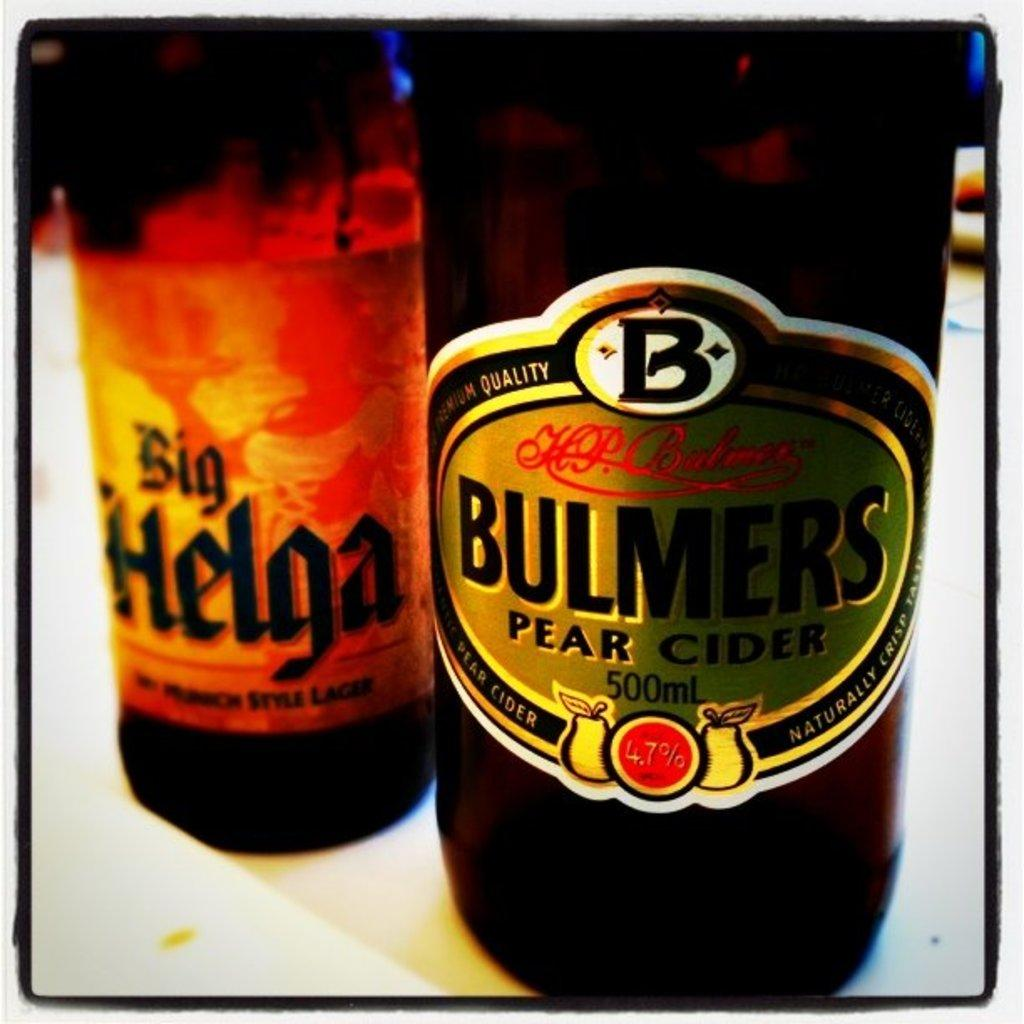<image>
Relay a brief, clear account of the picture shown. A bottle of Bulmers Pear Cider is next to a bottle of Sig Helga beer. 